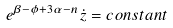Convert formula to latex. <formula><loc_0><loc_0><loc_500><loc_500>e ^ { \beta - \phi + 3 \alpha - n } \dot { z } = c o n s t a n t</formula> 